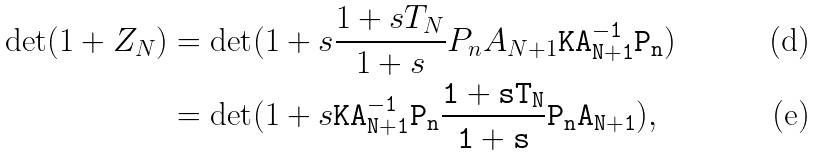Convert formula to latex. <formula><loc_0><loc_0><loc_500><loc_500>\det ( 1 + Z _ { N } ) & = \det ( 1 + s \frac { 1 + s T _ { N } } { 1 + s } P _ { n } A _ { N + 1 } \tt K A _ { N + 1 } ^ { - 1 } P _ { n } ) \\ & = \det ( 1 + s \tt K A _ { N + 1 } ^ { - 1 } P _ { n } \frac { 1 + s T _ { N } } { 1 + s } P _ { n } A _ { N + 1 } ) ,</formula> 